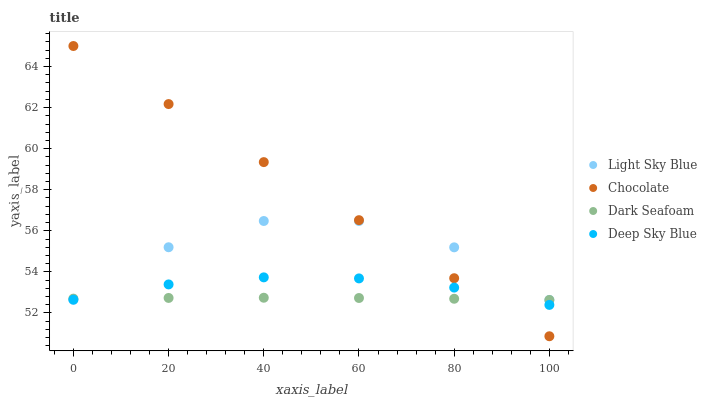Does Dark Seafoam have the minimum area under the curve?
Answer yes or no. Yes. Does Chocolate have the maximum area under the curve?
Answer yes or no. Yes. Does Light Sky Blue have the minimum area under the curve?
Answer yes or no. No. Does Light Sky Blue have the maximum area under the curve?
Answer yes or no. No. Is Chocolate the smoothest?
Answer yes or no. Yes. Is Light Sky Blue the roughest?
Answer yes or no. Yes. Is Deep Sky Blue the smoothest?
Answer yes or no. No. Is Deep Sky Blue the roughest?
Answer yes or no. No. Does Chocolate have the lowest value?
Answer yes or no. Yes. Does Deep Sky Blue have the lowest value?
Answer yes or no. No. Does Chocolate have the highest value?
Answer yes or no. Yes. Does Light Sky Blue have the highest value?
Answer yes or no. No. Does Deep Sky Blue intersect Light Sky Blue?
Answer yes or no. Yes. Is Deep Sky Blue less than Light Sky Blue?
Answer yes or no. No. Is Deep Sky Blue greater than Light Sky Blue?
Answer yes or no. No. 